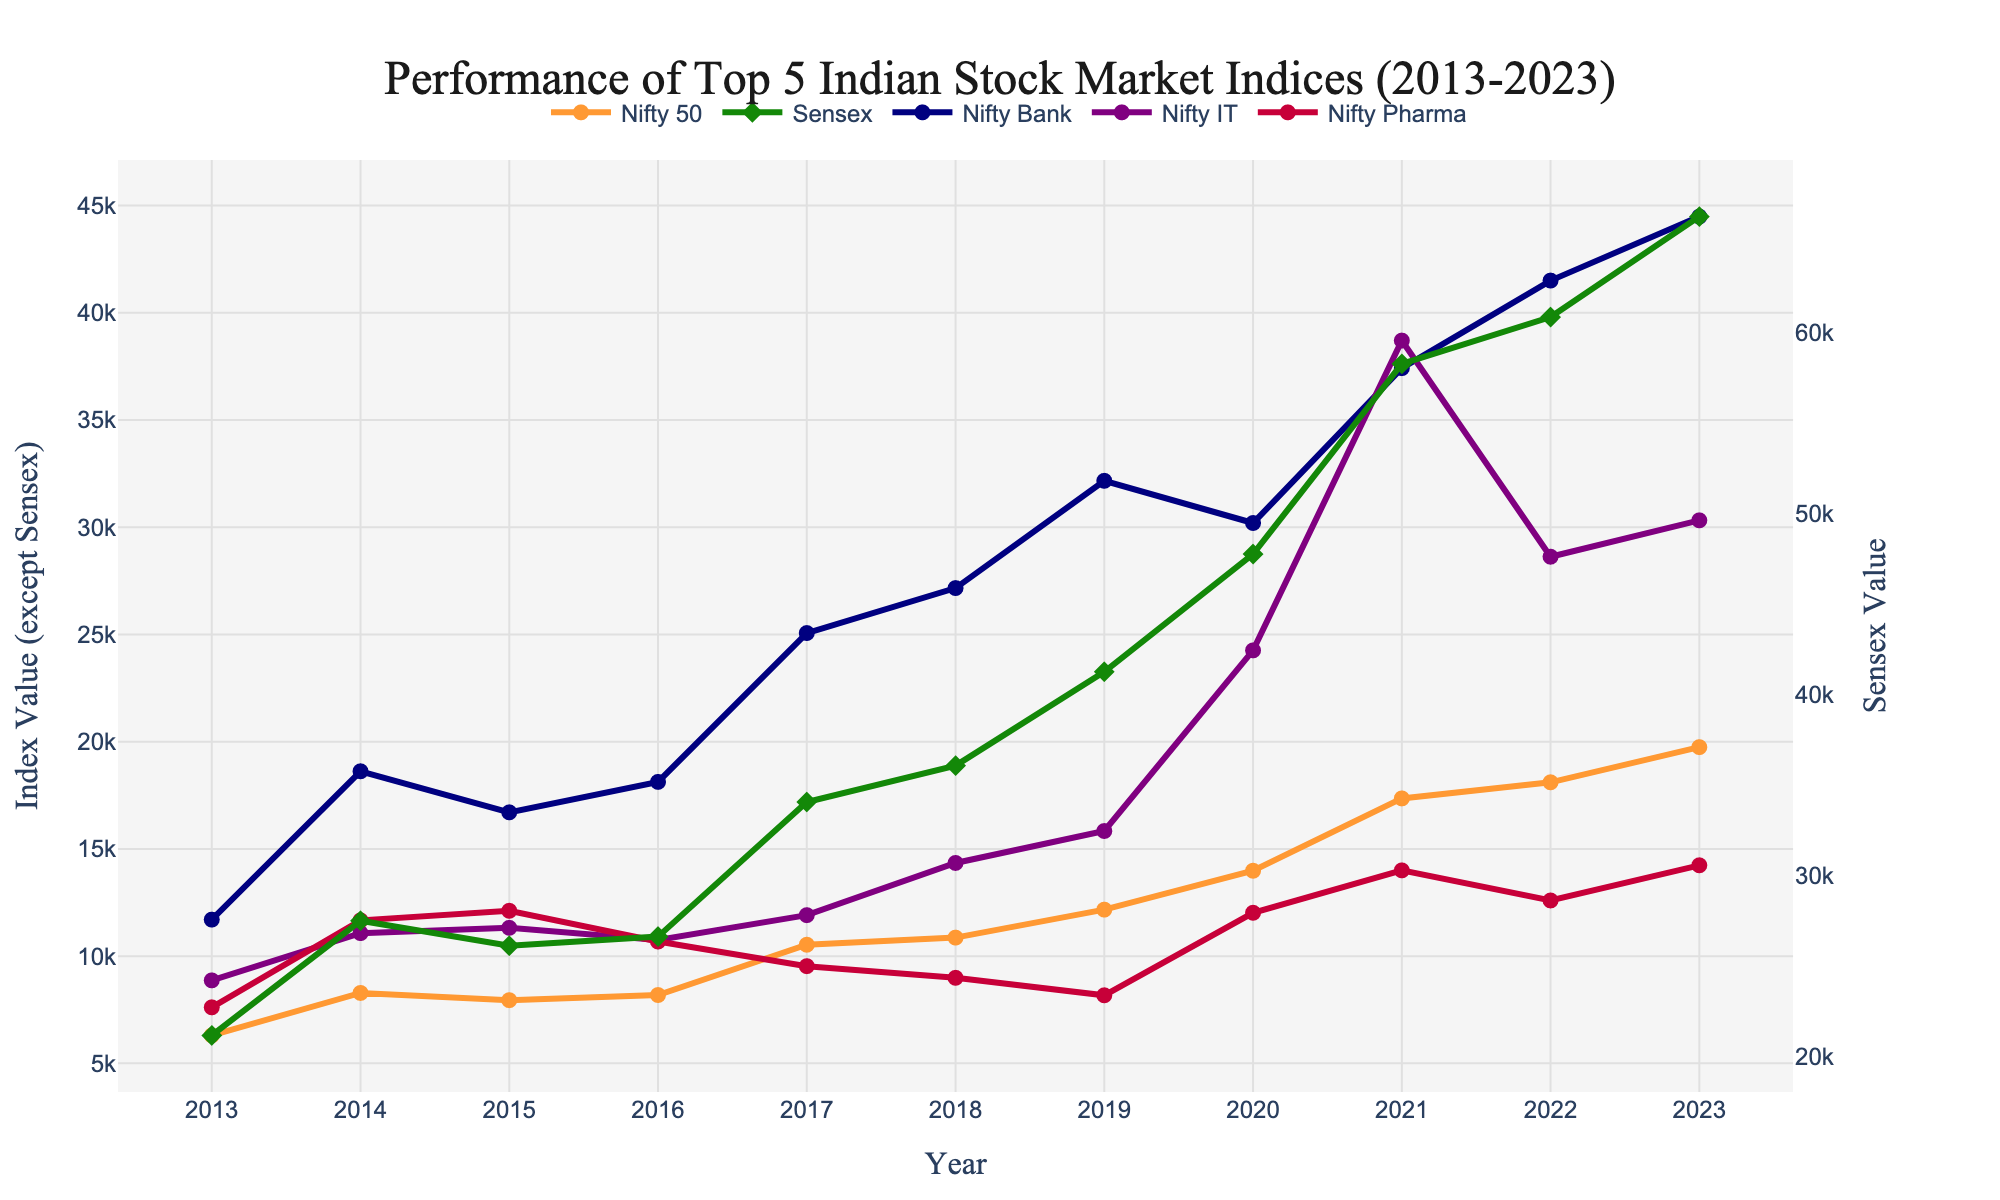Which index had the highest value in 2023? By visually inspecting the chart, locate the end value for each index on the x-axis marked as 2023. Compare these values to find the highest one.
Answer: Sensex How did the value of Nifty IT change from 2019 to 2021? Find the values of Nifty IT at the points corresponding to 2019 and 2021, then subtract the 2019 value from the 2021 value.
Answer: It increased by 22,867 What is the average value of Nifty Bank between 2015 and 2020? Identify the values of Nifty Bank for each year from 2015 to 2020: 16,705, 18,124, 25,064, 27,161, 32,162, and 30,196. Sum these values and then divide by the number of years (6).
Answer: 24,568.67 Which year showed the sharpest increase in Sensex value? Examine the yearly increments of Sensex values, and find the year with the largest difference from the previous year.
Answer: 2021 Compare the performance of Nifty Pharma to Nifty IT over the decade. Which saw a greater overall increase? Calculate the differences between the final and initial values for both Nifty Pharma and Nifty IT across the decade. Compare these differences to determine which index had a greater overall increase.
Answer: Nifty IT At which year did Nifty 50 first cross the 10,000 mark? Look at the graph for Nifty 50 and identify the first year where the index value exceeds 10,000.
Answer: 2017 Did Nifty Bank or Nifty Pharma have a higher value in 2018? Check the values of Nifty Bank and Nifty Pharma for the year 2018. Compare these values to determine which one is higher.
Answer: Nifty Bank What was the value difference between Sensex and Nifty 50 in 2023? Find the values of Sensex and Nifty 50 in 2023 and subtract the Nifty 50 value from the Sensex value.
Answer: 46,644 Which index consistently showed an upward trend throughout the decade? Examine the pattern of each index over the years to determine if any index continuously increased its value without any year showing a decrease.
Answer: Sensex Determine the compound annual growth rate (CAGR) of Nifty 50 from 2013 to 2023. Use the formula for CAGR: \( \text{CAGR} = \left(\frac{\text{Ending Value}}{\text{Beginning Value}}\right)^{\frac{1}{\text{Number of Years}}} - 1 \). Plug in the values for Nifty 50. Calculation: \( \left(\frac{19745}{6304}\right)^{\frac{1}{10}} - 1 \approx 0.114\) (or 11.4%).
Answer: 11.4% 